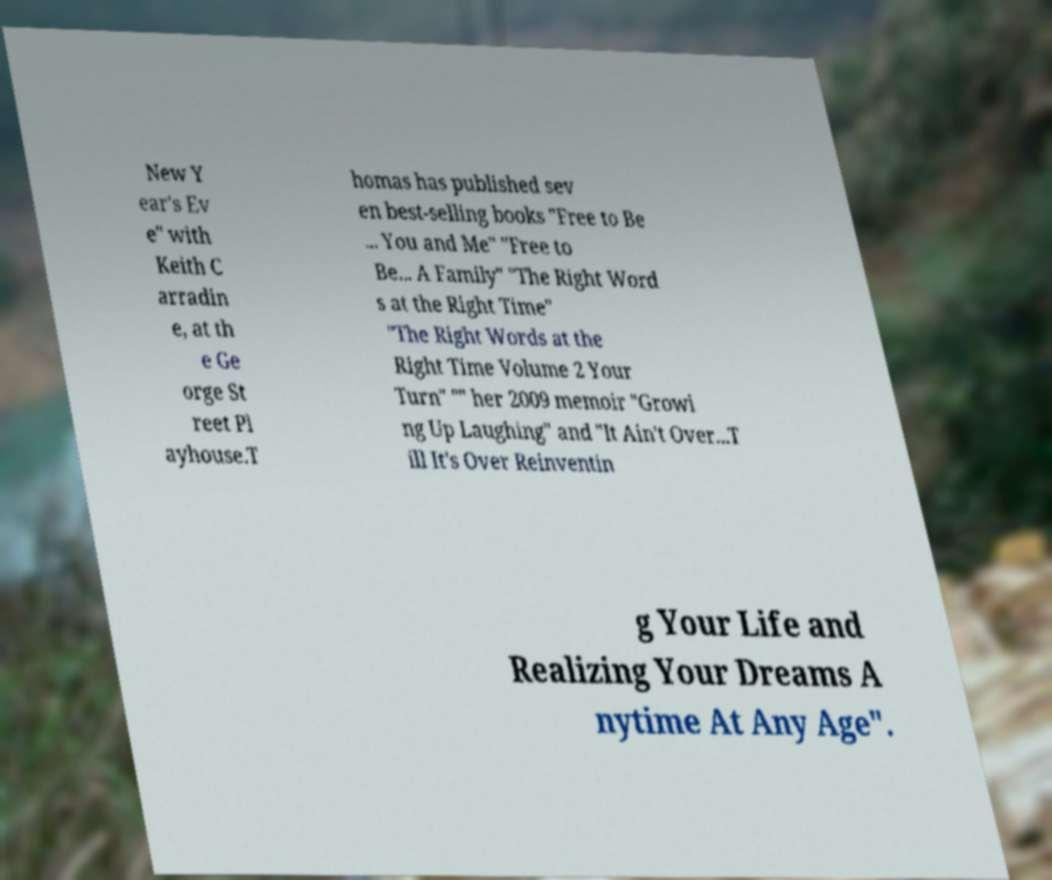Could you extract and type out the text from this image? New Y ear's Ev e" with Keith C arradin e, at th e Ge orge St reet Pl ayhouse.T homas has published sev en best-selling books "Free to Be ... You and Me" "Free to Be... A Family" "The Right Word s at the Right Time" "The Right Words at the Right Time Volume 2 Your Turn" "" her 2009 memoir "Growi ng Up Laughing" and "It Ain't Over...T ill It's Over Reinventin g Your Life and Realizing Your Dreams A nytime At Any Age". 